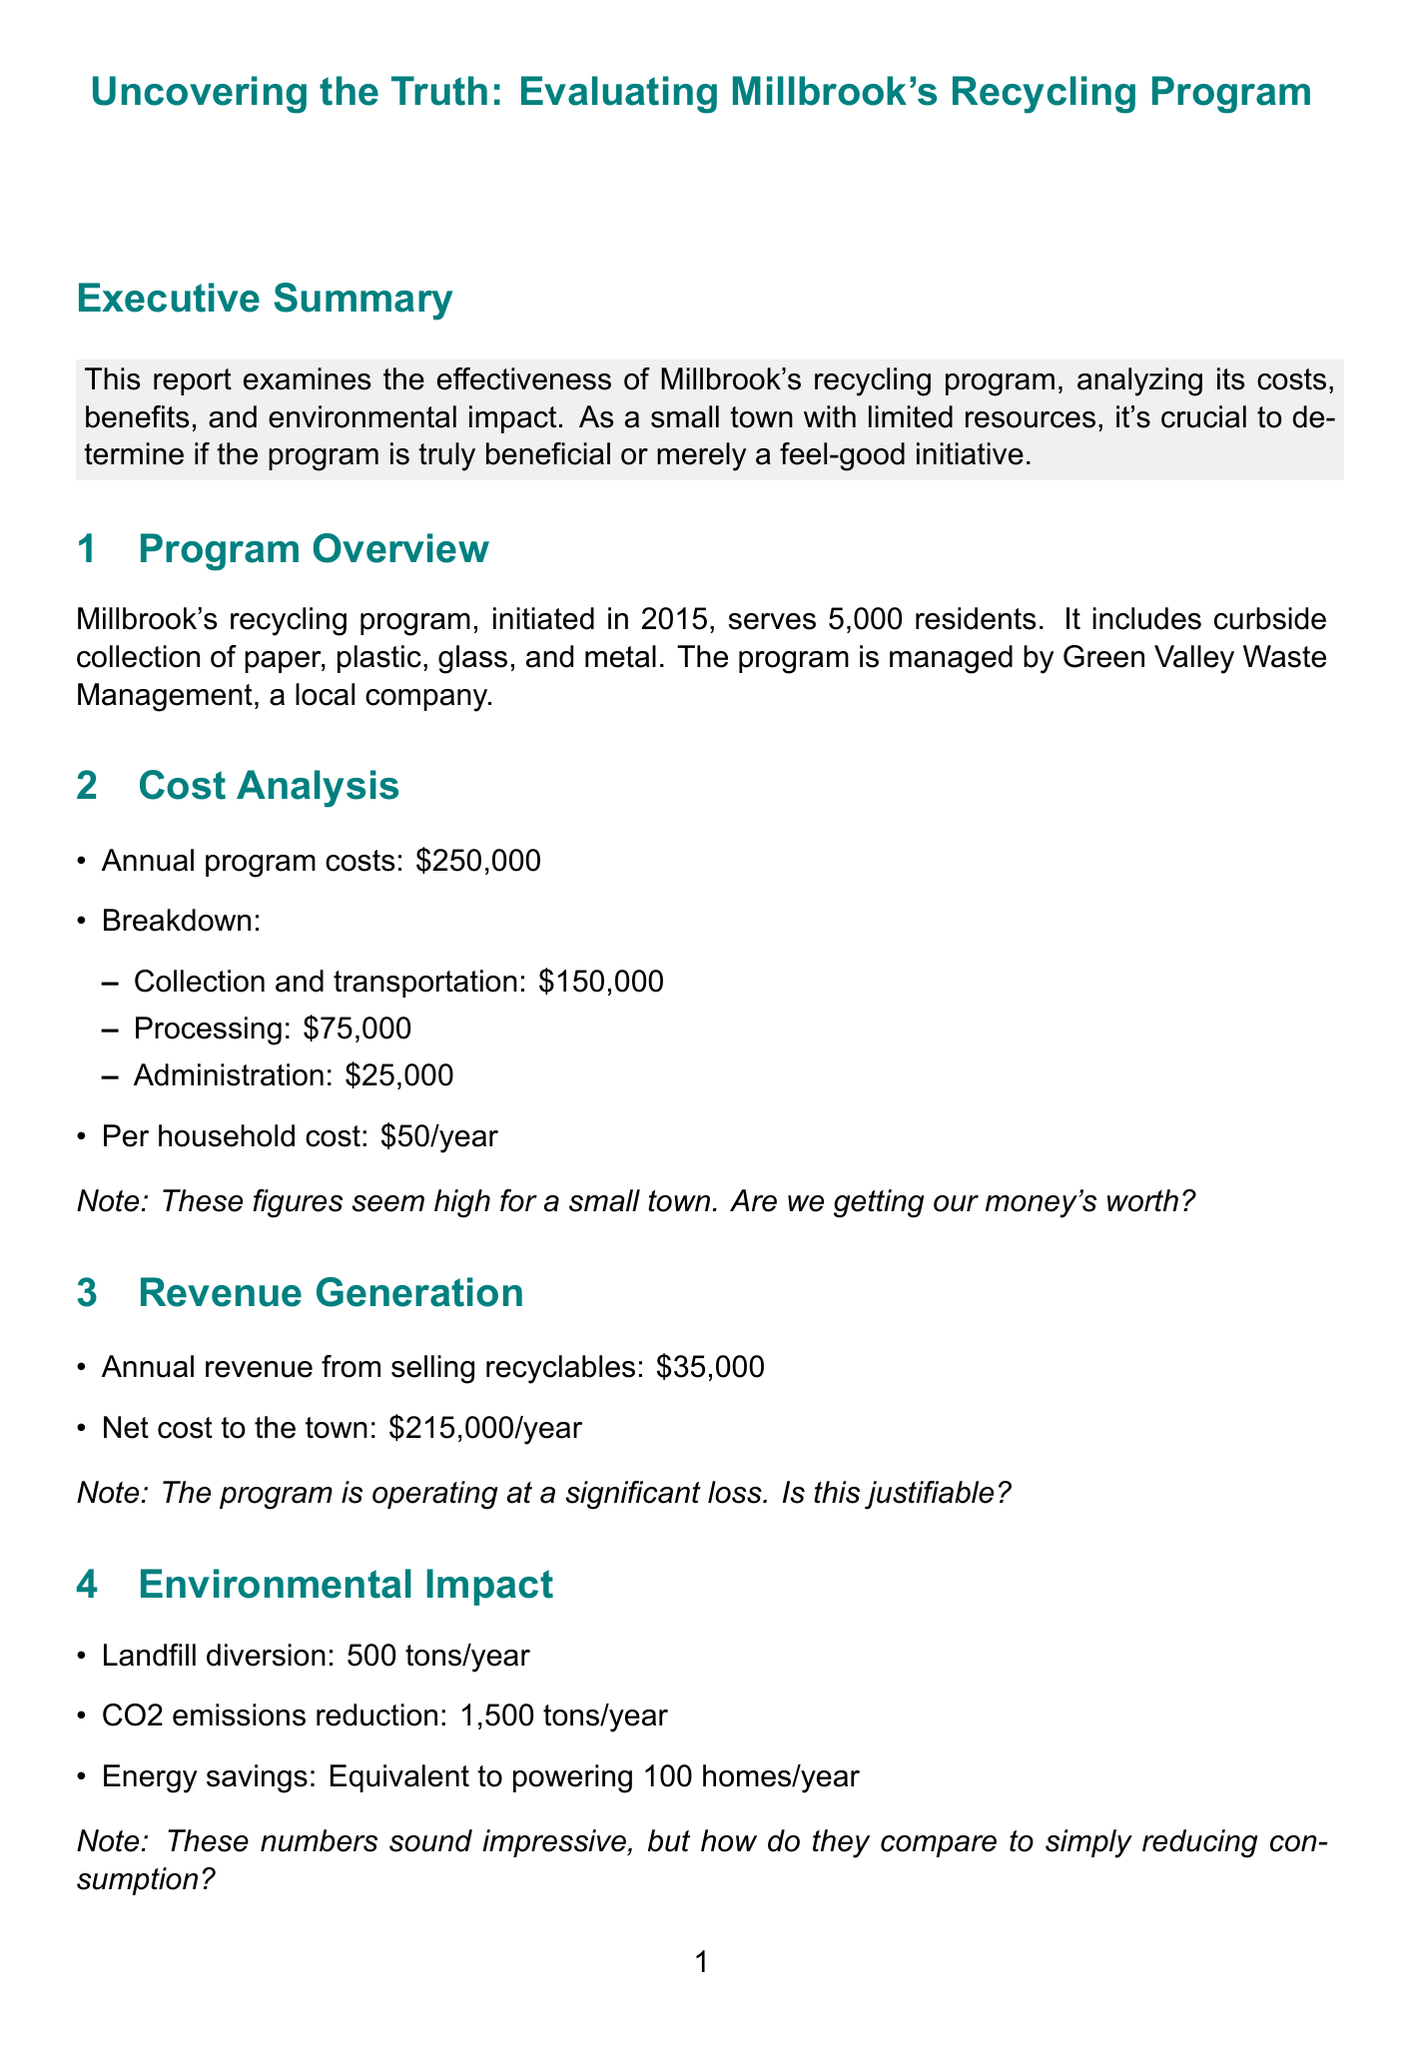What is the annual cost of the recycling program? The document states that the annual program costs are $250,000.
Answer: $250,000 What is the per household cost for the program? According to the Cost Analysis section, the per household cost is $50/year.
Answer: $50/year How much revenue does the town generate from selling recyclables? The report mentions that the annual revenue from selling recyclables is $35,000.
Answer: $35,000 What is the contamination rate of the recycling program? The Participation Rates section indicates that the contamination rate is 25%.
Answer: 25% What is the landfill diversion achieved by the program? The Environmental Impact section shows that the program diverts 500 tons of landfill waste per year.
Answer: 500 tons/year How does Millbrook's participation rate compare to Oakville's? Millbrook has a participation rate of 65%, while Oakville has a rate of 70%.
Answer: 65% vs. 70% What alternative approach is suggested for increasing recycling rates? The report mentions a bottle deposit system proposed by local business owner Tom Johnson.
Answer: Bottle deposit system What percentage of residents are satisfied with the program? The document states that 45% of residents are satisfied with the recycling program.
Answer: 45% What is the net cost to the town after revenue generation? The report calculates the net cost to the town as $215,000/year after accounting for revenue.
Answer: $215,000/year 